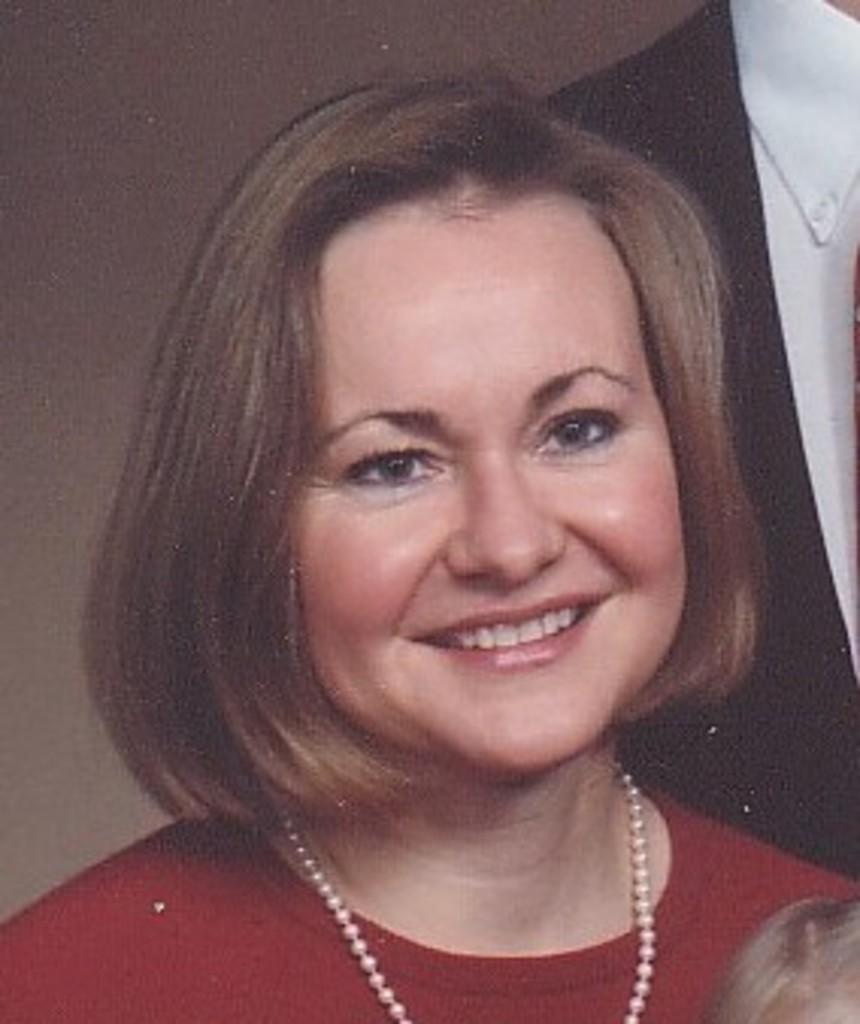Who is present in the image? There is a woman in the image. What type of vein is visible on the woman's forehead in the image? There is no vein visible on the woman's forehead in the image. What role does the woman play in the image, such as a manager or leader? The provided facts do not mention any specific role or title for the woman in the image. 